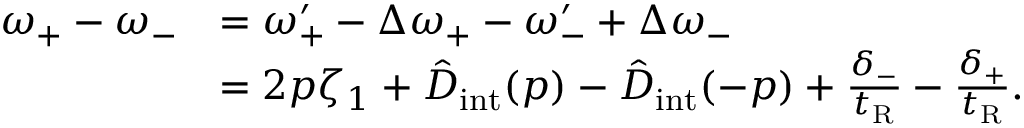<formula> <loc_0><loc_0><loc_500><loc_500>\begin{array} { r l } { \omega _ { + } - \omega _ { - } } & { = \omega _ { + } ^ { \prime } - \Delta \omega _ { + } - \omega _ { - } ^ { \prime } + \Delta \omega _ { - } } \\ & { = 2 p \zeta _ { 1 } + \hat { D } _ { i n t } ( p ) - \hat { D } _ { i n t } ( - p ) + \frac { \delta _ { - } } { t _ { R } } - \frac { \delta _ { + } } { t _ { R } } . } \end{array}</formula> 